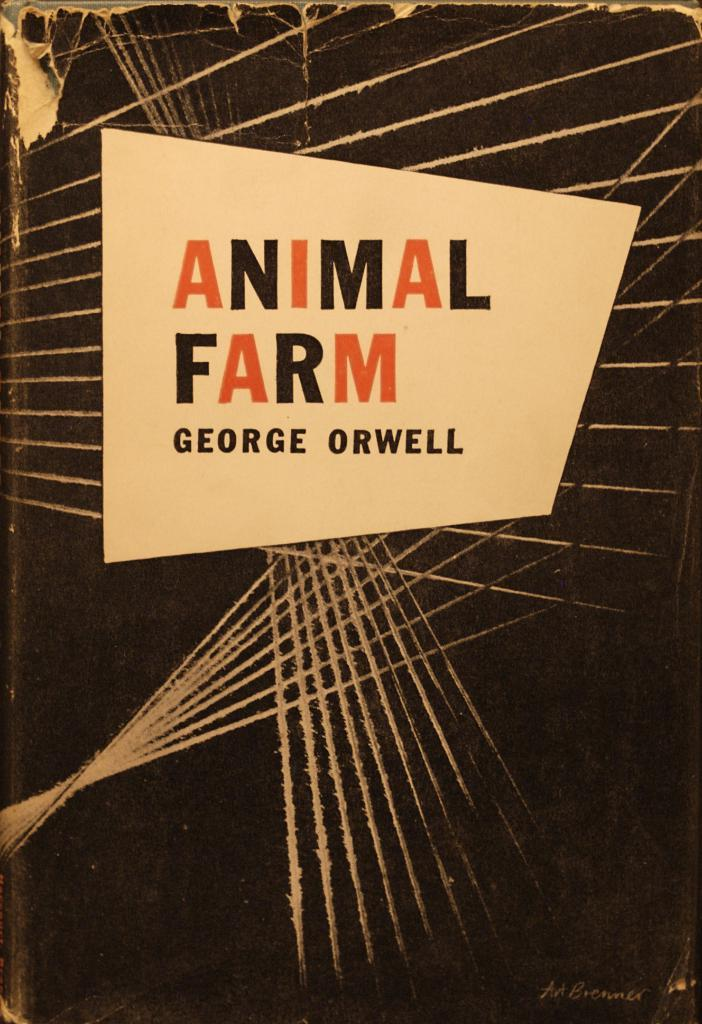<image>
Provide a brief description of the given image. The book by George Orwell is titled Animal Farm. 